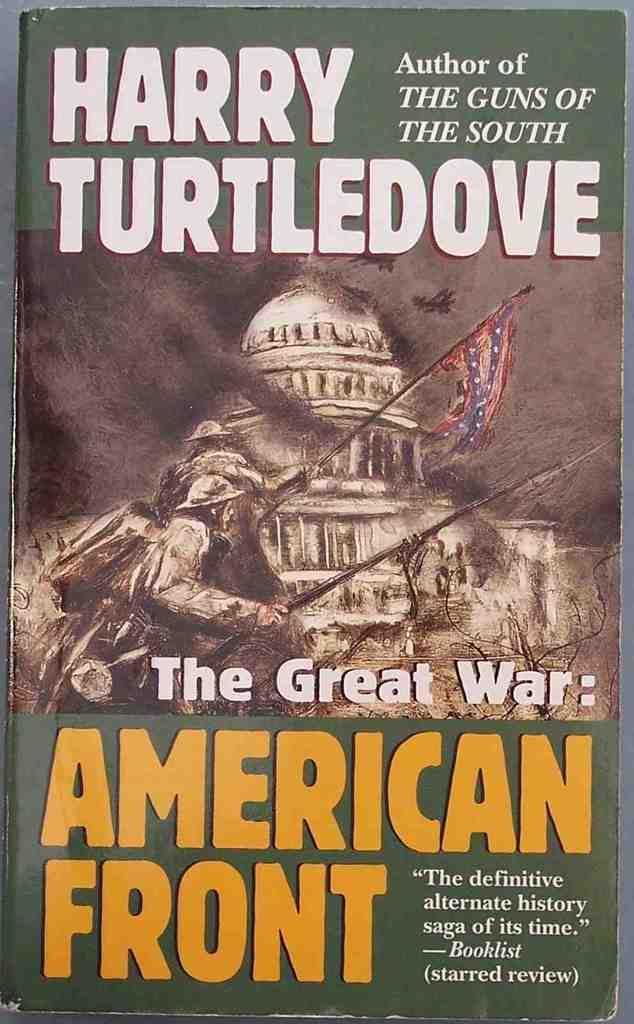<image>
Render a clear and concise summary of the photo. Harry Turtledove is the author of the book The Great American Front. 